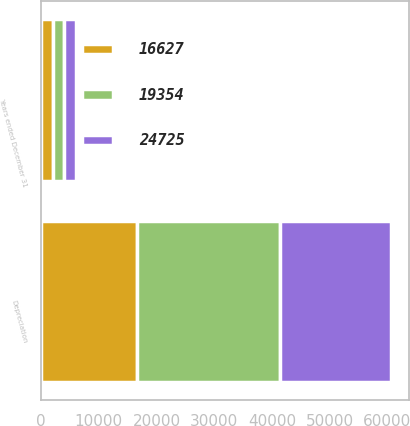Convert chart to OTSL. <chart><loc_0><loc_0><loc_500><loc_500><stacked_bar_chart><ecel><fcel>Years ended December 31<fcel>Depreciation<nl><fcel>19354<fcel>2016<fcel>24725<nl><fcel>24725<fcel>2015<fcel>19354<nl><fcel>16627<fcel>2014<fcel>16627<nl></chart> 